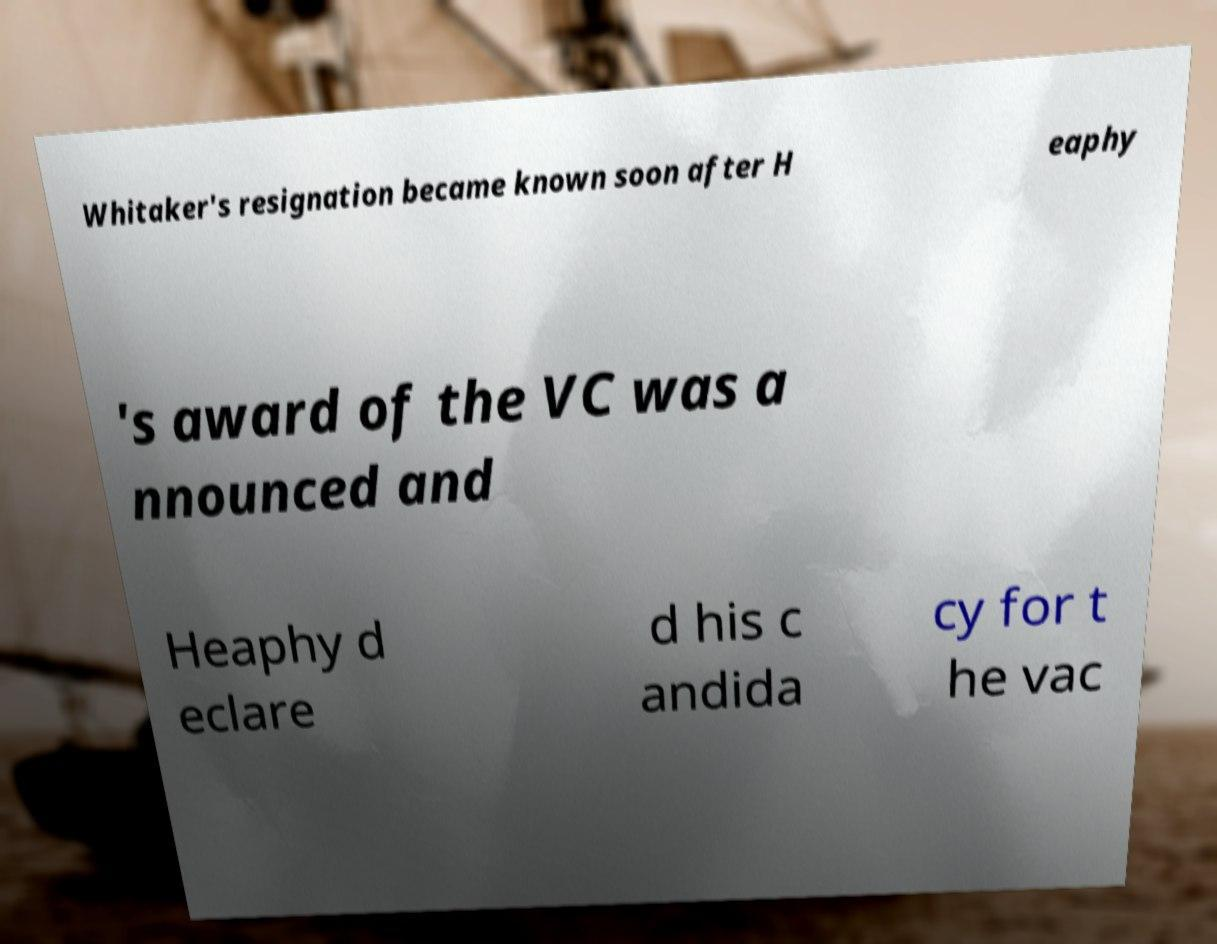Could you assist in decoding the text presented in this image and type it out clearly? Whitaker's resignation became known soon after H eaphy 's award of the VC was a nnounced and Heaphy d eclare d his c andida cy for t he vac 